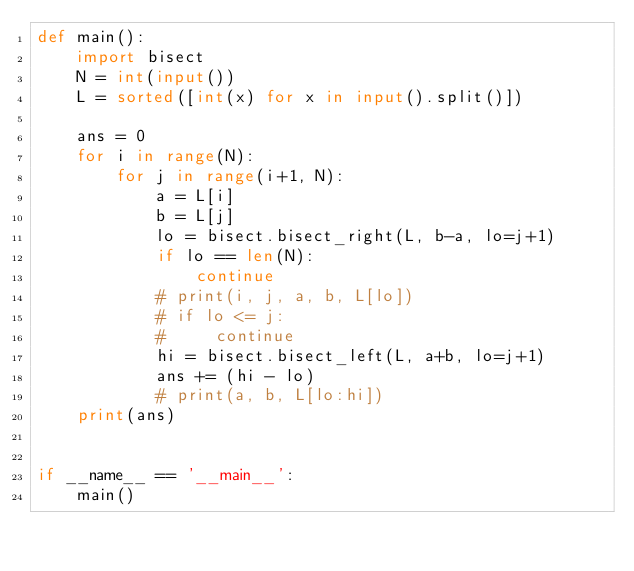Convert code to text. <code><loc_0><loc_0><loc_500><loc_500><_Python_>def main():
    import bisect
    N = int(input())
    L = sorted([int(x) for x in input().split()])

    ans = 0
    for i in range(N):
        for j in range(i+1, N):
            a = L[i]
            b = L[j]
            lo = bisect.bisect_right(L, b-a, lo=j+1)
            if lo == len(N):
                continue 
            # print(i, j, a, b, L[lo])
            # if lo <= j:
            #     continue
            hi = bisect.bisect_left(L, a+b, lo=j+1)
            ans += (hi - lo)
            # print(a, b, L[lo:hi])
    print(ans)


if __name__ == '__main__':
    main()</code> 